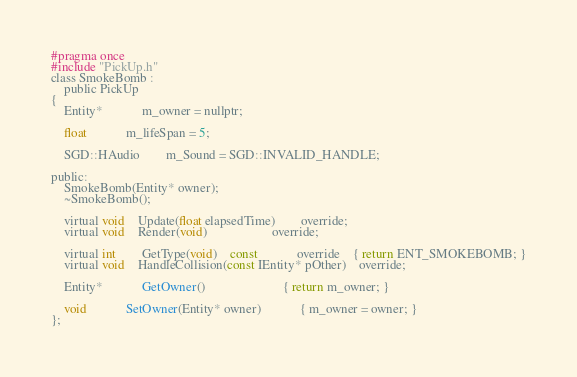Convert code to text. <code><loc_0><loc_0><loc_500><loc_500><_C_>#pragma once
#include "PickUp.h"
class SmokeBomb :
	public PickUp
{
	Entity*			m_owner = nullptr;

	float			m_lifeSpan = 5;

	SGD::HAudio		m_Sound = SGD::INVALID_HANDLE;

public:
	SmokeBomb(Entity* owner);
	~SmokeBomb();

	virtual void	Update(float elapsedTime)		override;
	virtual void	Render(void)					override;

	virtual int		GetType(void)	const			override	{ return ENT_SMOKEBOMB; }
	virtual void	HandleCollision(const IEntity* pOther)	override;

	Entity*			GetOwner()						{ return m_owner; }

	void			SetOwner(Entity* owner)			{ m_owner = owner; }
};</code> 